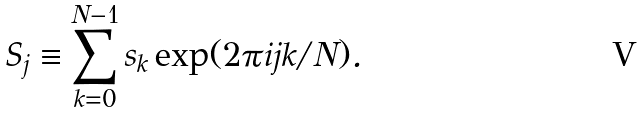<formula> <loc_0><loc_0><loc_500><loc_500>S _ { j } \equiv \sum _ { k = 0 } ^ { N - 1 } s _ { k } \exp ( 2 \pi i j k / N ) .</formula> 